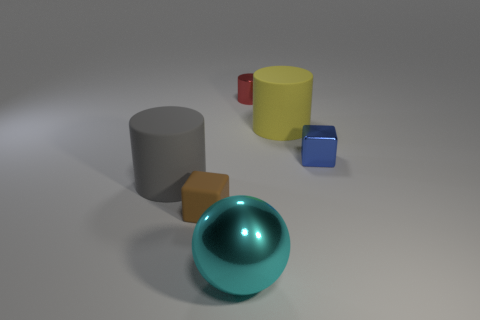Subtract all yellow cylinders. How many cylinders are left? 2 Subtract all yellow cylinders. How many cylinders are left? 2 Subtract 1 cubes. How many cubes are left? 1 Add 4 small blue things. How many objects exist? 10 Subtract 1 cyan spheres. How many objects are left? 5 Subtract all spheres. How many objects are left? 5 Subtract all green spheres. Subtract all brown cylinders. How many spheres are left? 1 Subtract all cyan cubes. How many red cylinders are left? 1 Subtract all small brown matte things. Subtract all tiny cubes. How many objects are left? 3 Add 4 big cylinders. How many big cylinders are left? 6 